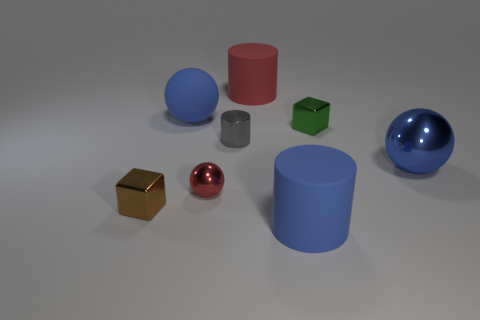Add 2 large red cylinders. How many objects exist? 10 Subtract all metal spheres. How many spheres are left? 1 Subtract 1 cylinders. How many cylinders are left? 2 Subtract all red spheres. How many spheres are left? 2 Subtract all cylinders. How many objects are left? 5 Subtract 0 gray balls. How many objects are left? 8 Subtract all yellow cylinders. Subtract all brown spheres. How many cylinders are left? 3 Subtract all purple blocks. How many red balls are left? 1 Subtract all large brown rubber cylinders. Subtract all tiny gray metal cylinders. How many objects are left? 7 Add 8 large red cylinders. How many large red cylinders are left? 9 